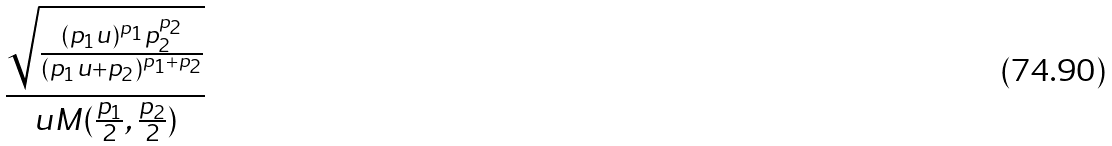<formula> <loc_0><loc_0><loc_500><loc_500>\frac { \sqrt { \frac { ( p _ { 1 } u ) ^ { p _ { 1 } } p _ { 2 } ^ { p _ { 2 } } } { ( p _ { 1 } u + p _ { 2 } ) ^ { p _ { 1 } + p _ { 2 } } } } } { u M ( \frac { p _ { 1 } } { 2 } , \frac { p _ { 2 } } { 2 } ) }</formula> 